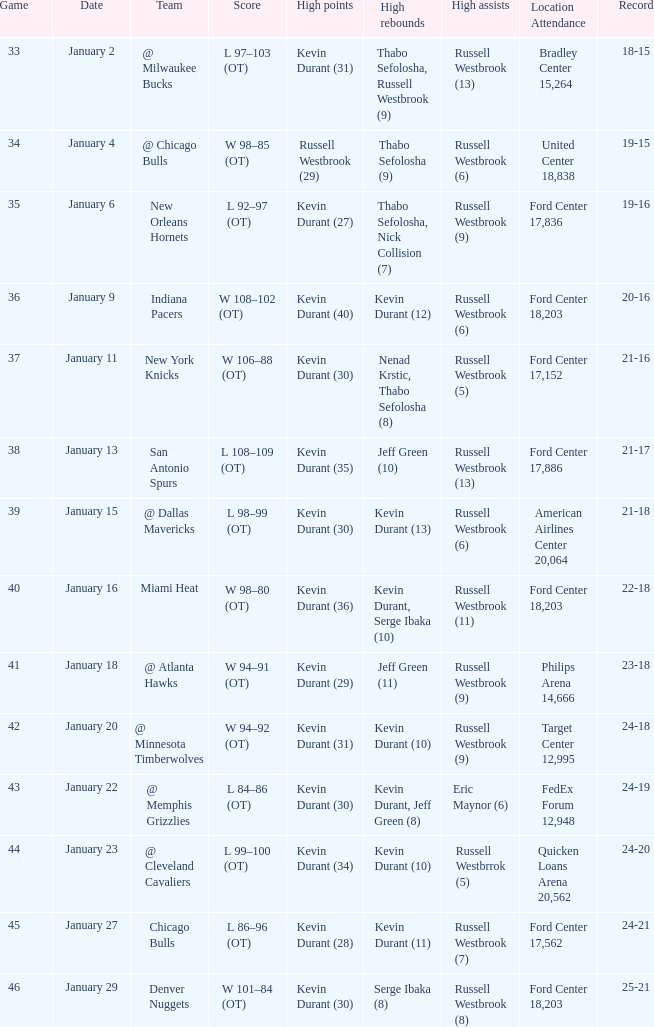Name the least game for january 29 46.0. 